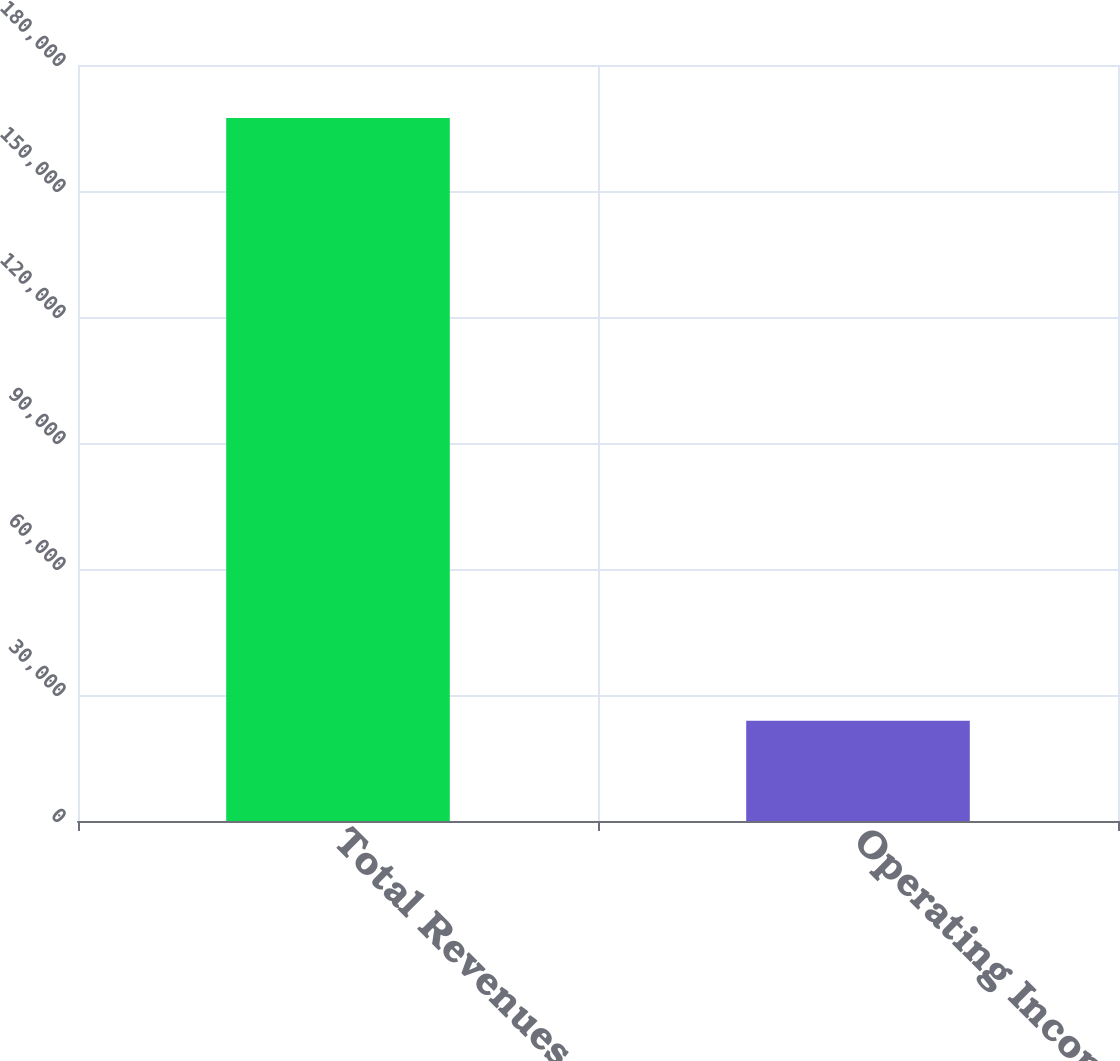Convert chart to OTSL. <chart><loc_0><loc_0><loc_500><loc_500><bar_chart><fcel>Total Revenues<fcel>Operating Income<nl><fcel>167368<fcel>23861<nl></chart> 